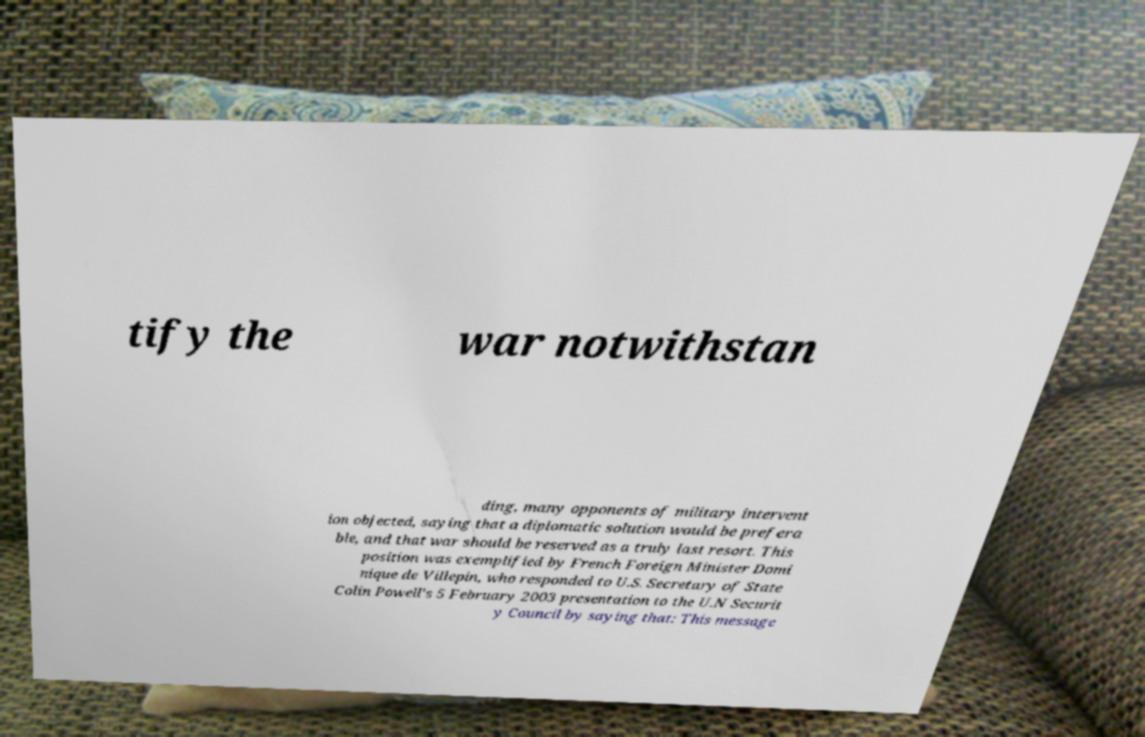Could you assist in decoding the text presented in this image and type it out clearly? tify the war notwithstan ding, many opponents of military intervent ion objected, saying that a diplomatic solution would be prefera ble, and that war should be reserved as a truly last resort. This position was exemplified by French Foreign Minister Domi nique de Villepin, who responded to U.S. Secretary of State Colin Powell's 5 February 2003 presentation to the U.N Securit y Council by saying that: This message 